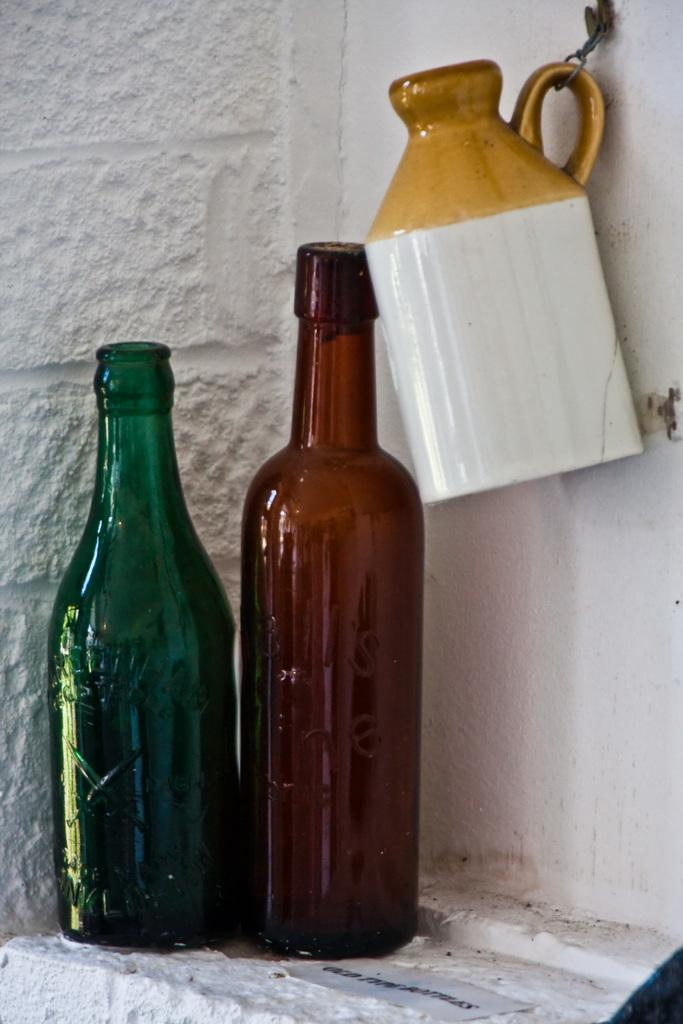How many bottles are visible in the image? There are two bottles in the image. What other container can be seen in the image? There is a jar in the image. Where is the jar located in the image? The jar is hanged on the wall. What is the color of the wall in the background of the image? The background of the image includes a white wall. What type of list is being used by the governor in the image? There is no governor or list present in the image. Can you hear a whistle in the image? There is no whistle present in the image. 